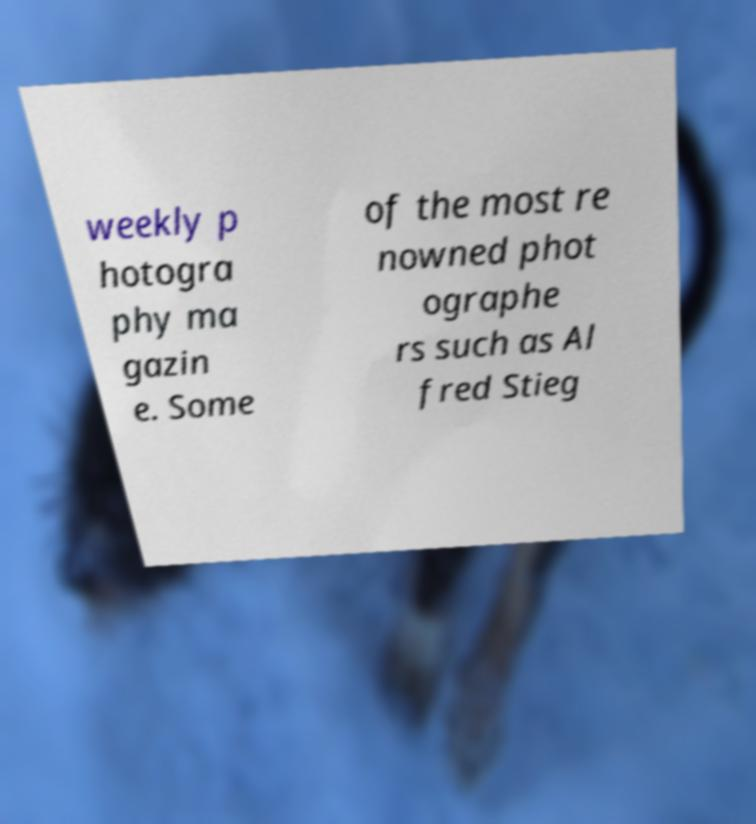Can you read and provide the text displayed in the image?This photo seems to have some interesting text. Can you extract and type it out for me? weekly p hotogra phy ma gazin e. Some of the most re nowned phot ographe rs such as Al fred Stieg 